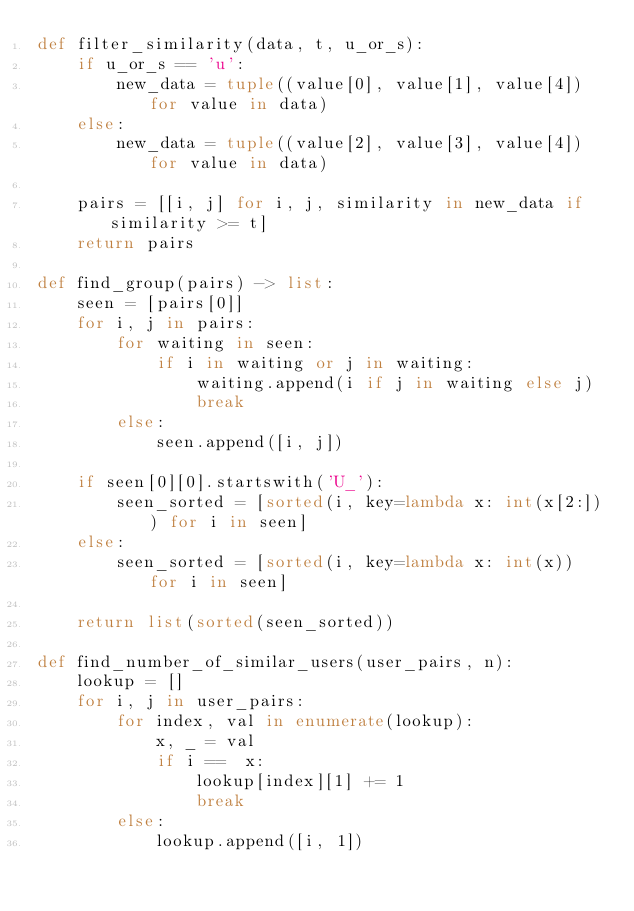<code> <loc_0><loc_0><loc_500><loc_500><_Python_>def filter_similarity(data, t, u_or_s):
    if u_or_s == 'u':
        new_data = tuple((value[0], value[1], value[4]) for value in data)
    else:
        new_data = tuple((value[2], value[3], value[4]) for value in data)

    pairs = [[i, j] for i, j, similarity in new_data if similarity >= t] 
    return pairs

def find_group(pairs) -> list:
    seen = [pairs[0]]
    for i, j in pairs:
        for waiting in seen:
            if i in waiting or j in waiting:
                waiting.append(i if j in waiting else j)
                break
        else:
            seen.append([i, j])

    if seen[0][0].startswith('U_'):
        seen_sorted = [sorted(i, key=lambda x: int(x[2:])) for i in seen]
    else:
        seen_sorted = [sorted(i, key=lambda x: int(x)) for i in seen]

    return list(sorted(seen_sorted))

def find_number_of_similar_users(user_pairs, n):
    lookup = []
    for i, j in user_pairs:
        for index, val in enumerate(lookup):
            x, _ = val
            if i ==  x:
                lookup[index][1] += 1
                break
        else:
            lookup.append([i, 1])
</code> 